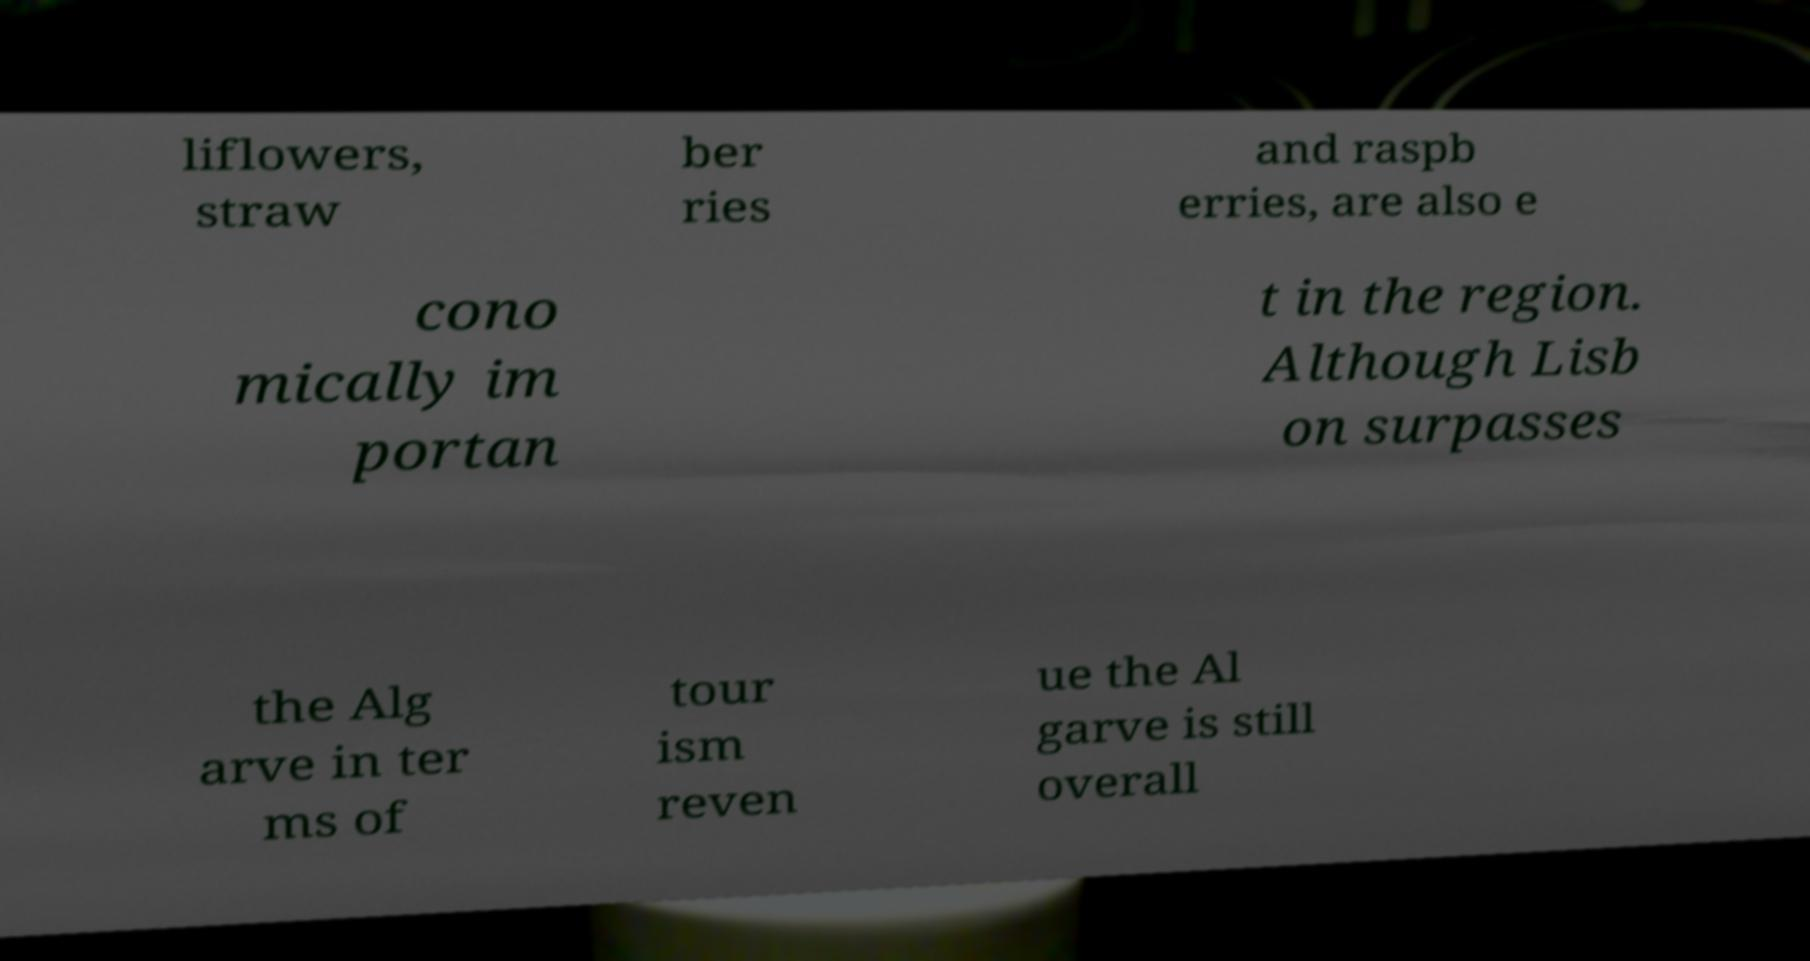I need the written content from this picture converted into text. Can you do that? liflowers, straw ber ries and raspb erries, are also e cono mically im portan t in the region. Although Lisb on surpasses the Alg arve in ter ms of tour ism reven ue the Al garve is still overall 